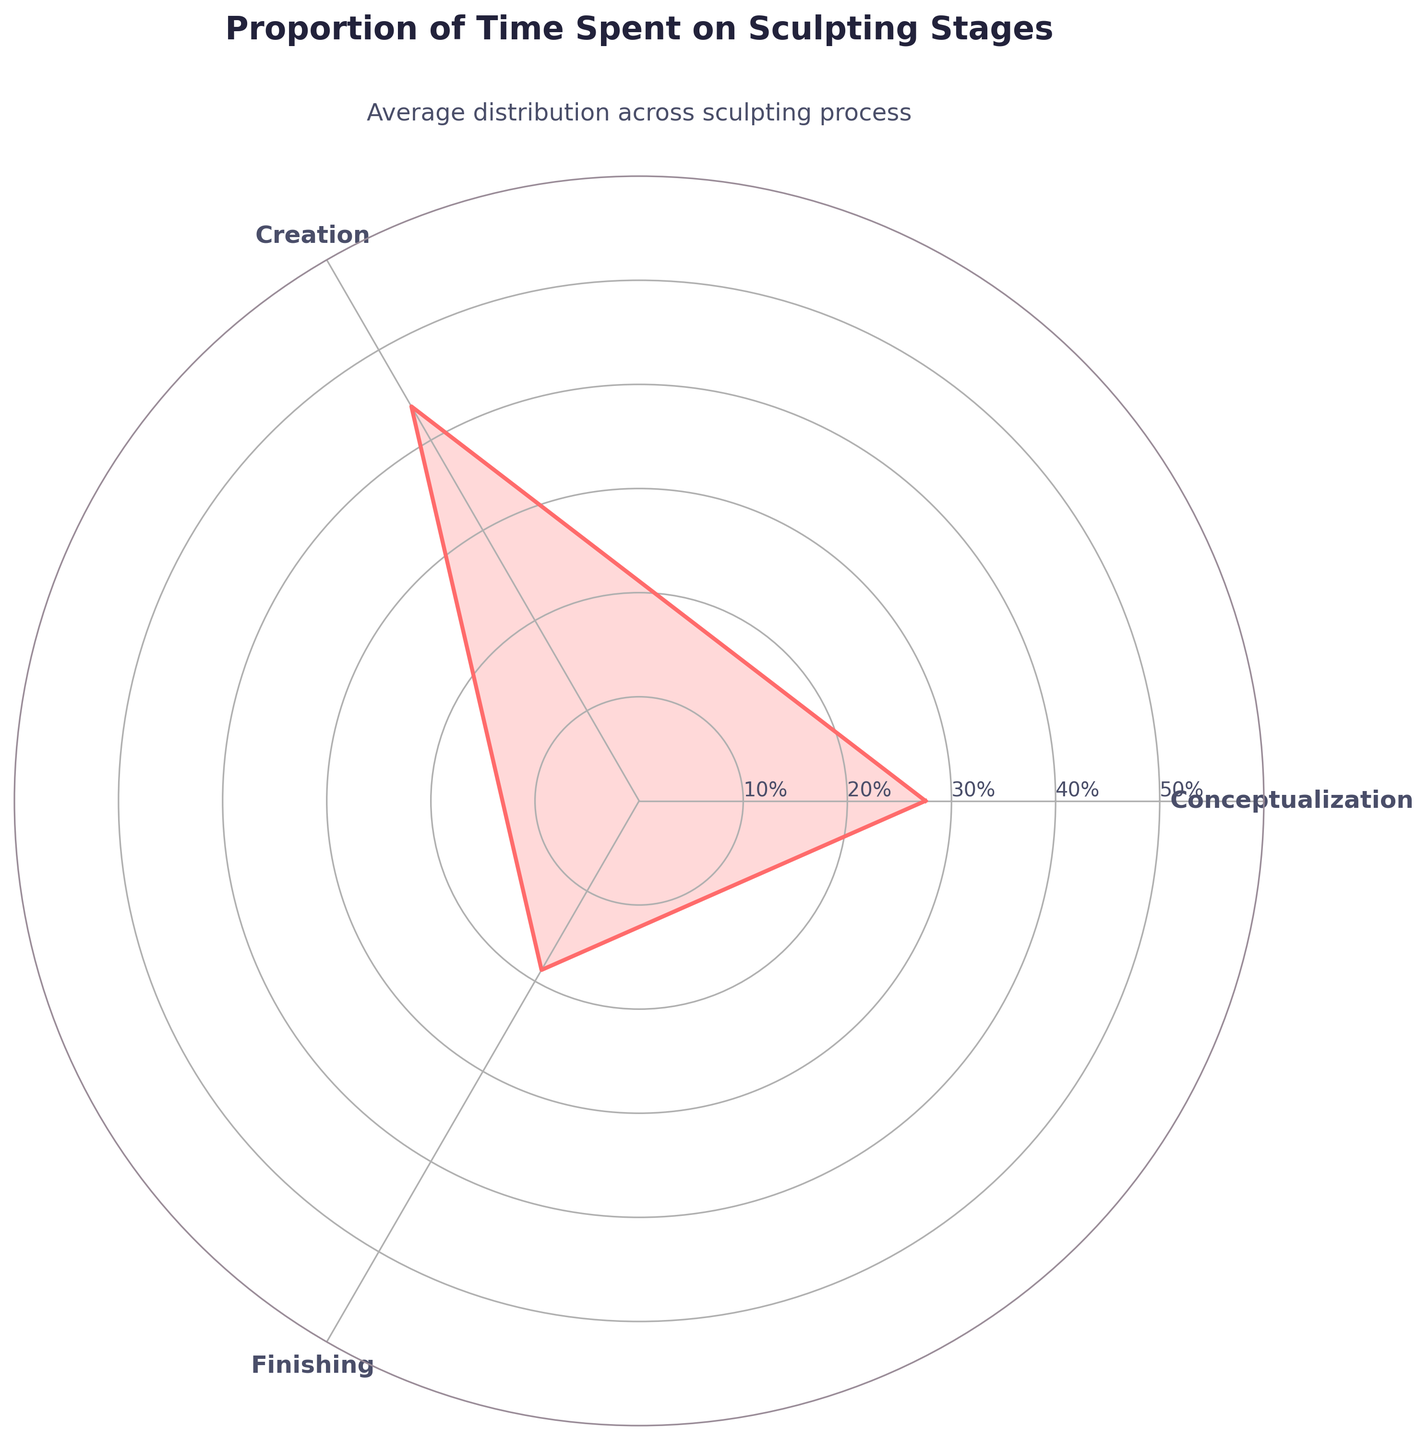What's the title of the plot? The title is displayed at the top center of the chart. It reads "Proportion of Time Spent on Sculpting Stages."
Answer: Proportion of Time Spent on Sculpting Stages What are the categories shown on the plot? The categories are usually indicated by the labels on the radial axes. They are "Conceptualization", "Creation", and "Finishing".
Answer: Conceptualization, Creation, Finishing What color is used for the fill in the plot? The fill color can be visually identified and is a shade of light red.
Answer: light red What's the average proportion of time spent on Creation? To find the average for Creation, look at the radial point on the axis labeled "Creation". It intersects at 43.75%, calculated as the average of (50%, 40%, 45%, 40%).
Answer: 43.75% How does the proportion of time spent on Conceptualization compare to Creation? Compare the radial lengths for "Conceptualization" and "Creation". Conceptualization is shorter than Creation, indicating less time is spent on Conceptualization on average.
Answer: less What's the maximum radial value shown? The outermost line on the radial axis gives the maximum value, which is 50%.
Answer: 50% Which stage of the sculpting process has the smallest average proportion of time committed? Compare the values for Conceptualization, Creation, and Finishing. Finishing, with an average of 18.75%, is the smallest among them.
Answer: Finishing What's the average radial value for all the categories? Compute the average of the average values shown: (27.5% + 43.75% + 18.75%) / 3. This equals approximately 30%.
Answer: 30% What's the sum of the average proportions of time spent on Conceptualization and Finishing? Add the values of Conceptualization and Finishing: 27.5% + 18.75% = 46.25%.
Answer: 46.25% What proportion of time does the radial axis represent? The radial axis increments in steps from 10% to 50%, representing the percentage of time spent.
Answer: percentages 